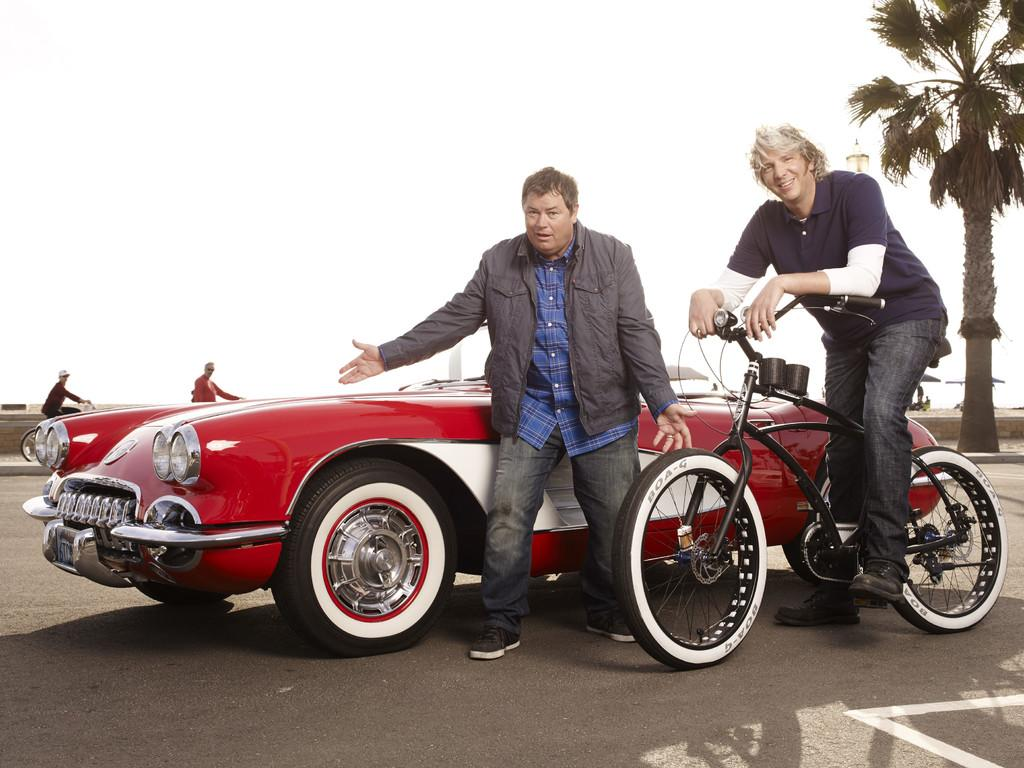What is the primary action of the person in the image? There is a person standing in the image. What is the person sitting doing in the image? The person sitting is holding a bicycle. What type of vehicle can be seen on the road in the image? There is a car visible on the road in the image. What can be seen in the background of the image? The sky and a tree are visible in the background of the image. Are there any other people visible in the image? Yes, there are other persons visible in the background of the image. What is the angle of the person's elbow in the image? There is no information about the angle of the person's elbow in the image, as it is not mentioned in the provided facts. 